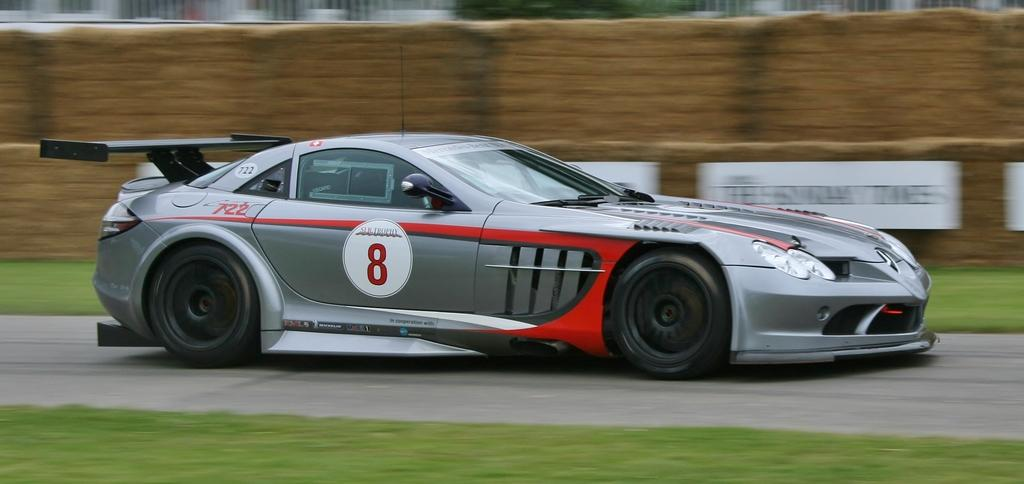What type of vehicle is in the foreground of the image? There is a sports car in the foreground of the image. What type of terrain is visible in the foreground of the image? There is grassland in the foreground of the image. What can be said about the background of the image? The background of the image is not clear. What type of bread can be seen in the image? There is no bread present in the image. 